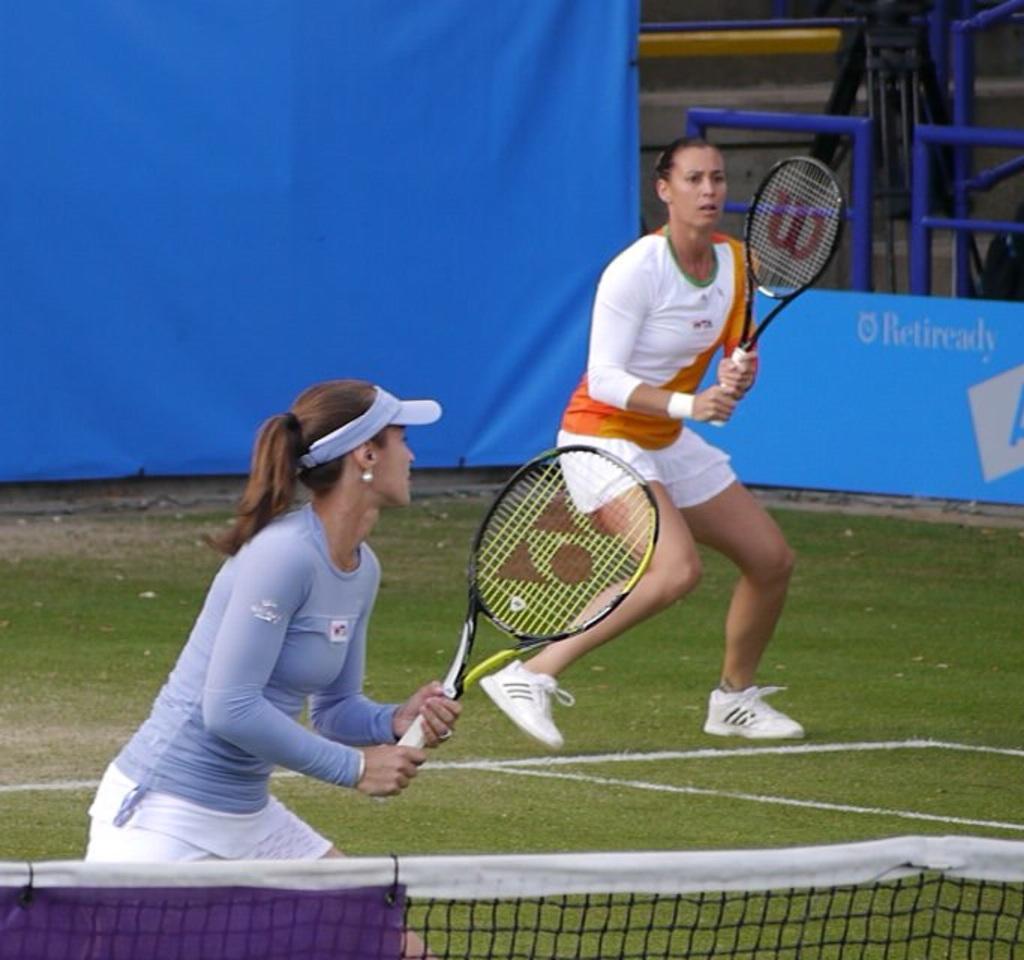How would you summarize this image in a sentence or two? Two women are playing tennis. Of them one is wearing a white t shirt with orange stripe on it. The other is wearing a pale blue shirt. There is a blue color screen behind them. 